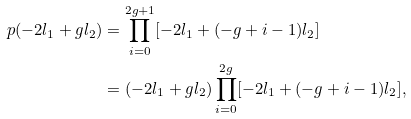<formula> <loc_0><loc_0><loc_500><loc_500>p ( - 2 l _ { 1 } + g l _ { 2 } ) & = \prod _ { i = 0 } ^ { 2 g + 1 } [ - 2 l _ { 1 } + ( - g + i - 1 ) l _ { 2 } ] \\ & = ( - 2 l _ { 1 } + g l _ { 2 } ) \prod _ { i = 0 } ^ { 2 g } [ - 2 l _ { 1 } + ( - g + i - 1 ) l _ { 2 } ] ,</formula> 